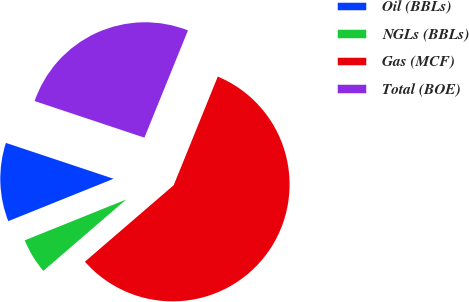Convert chart. <chart><loc_0><loc_0><loc_500><loc_500><pie_chart><fcel>Oil (BBLs)<fcel>NGLs (BBLs)<fcel>Gas (MCF)<fcel>Total (BOE)<nl><fcel>11.21%<fcel>5.23%<fcel>57.55%<fcel>26.02%<nl></chart> 